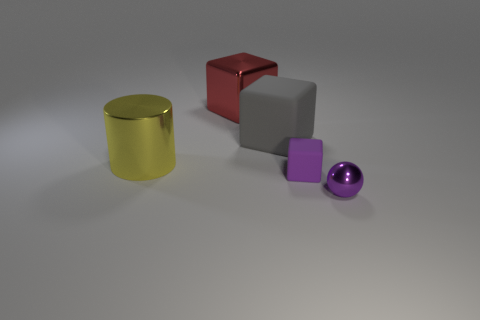Subtract all red spheres. Subtract all cyan cylinders. How many spheres are left? 1 Add 4 purple balls. How many objects exist? 9 Subtract all balls. How many objects are left? 4 Add 1 large yellow cylinders. How many large yellow cylinders are left? 2 Add 5 red metal cubes. How many red metal cubes exist? 6 Subtract 0 blue balls. How many objects are left? 5 Subtract all big gray objects. Subtract all yellow shiny cylinders. How many objects are left? 3 